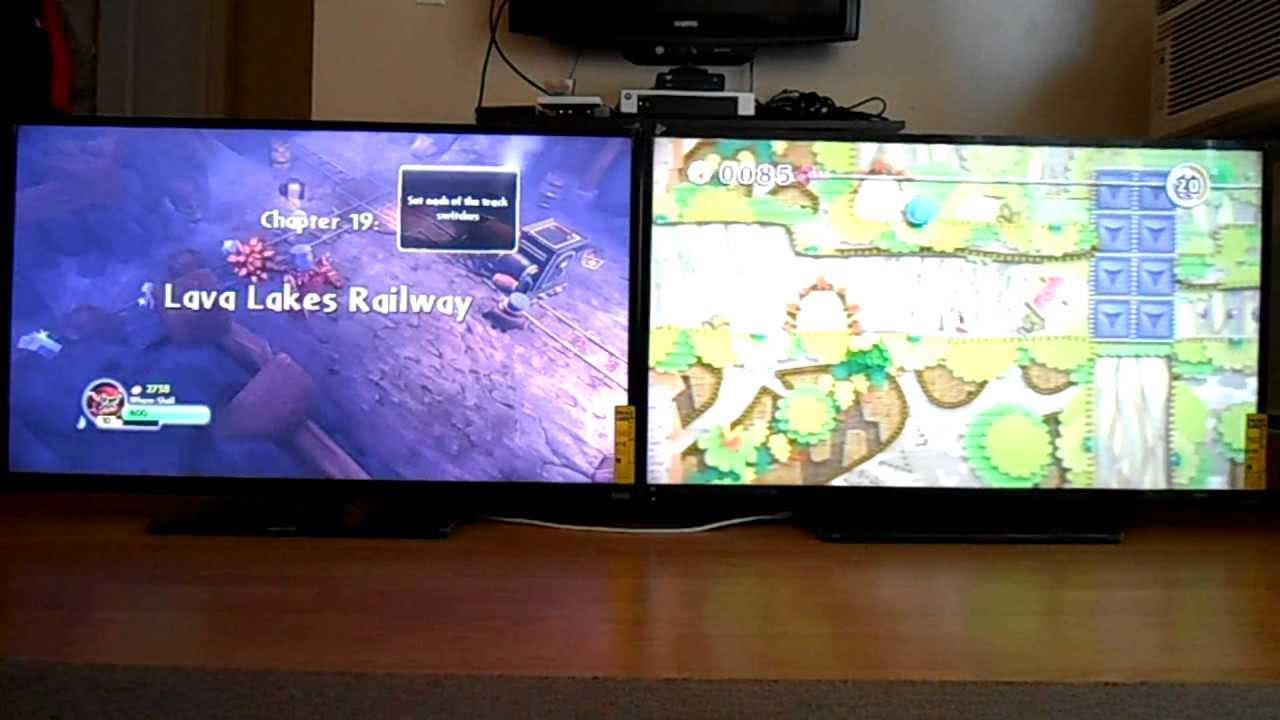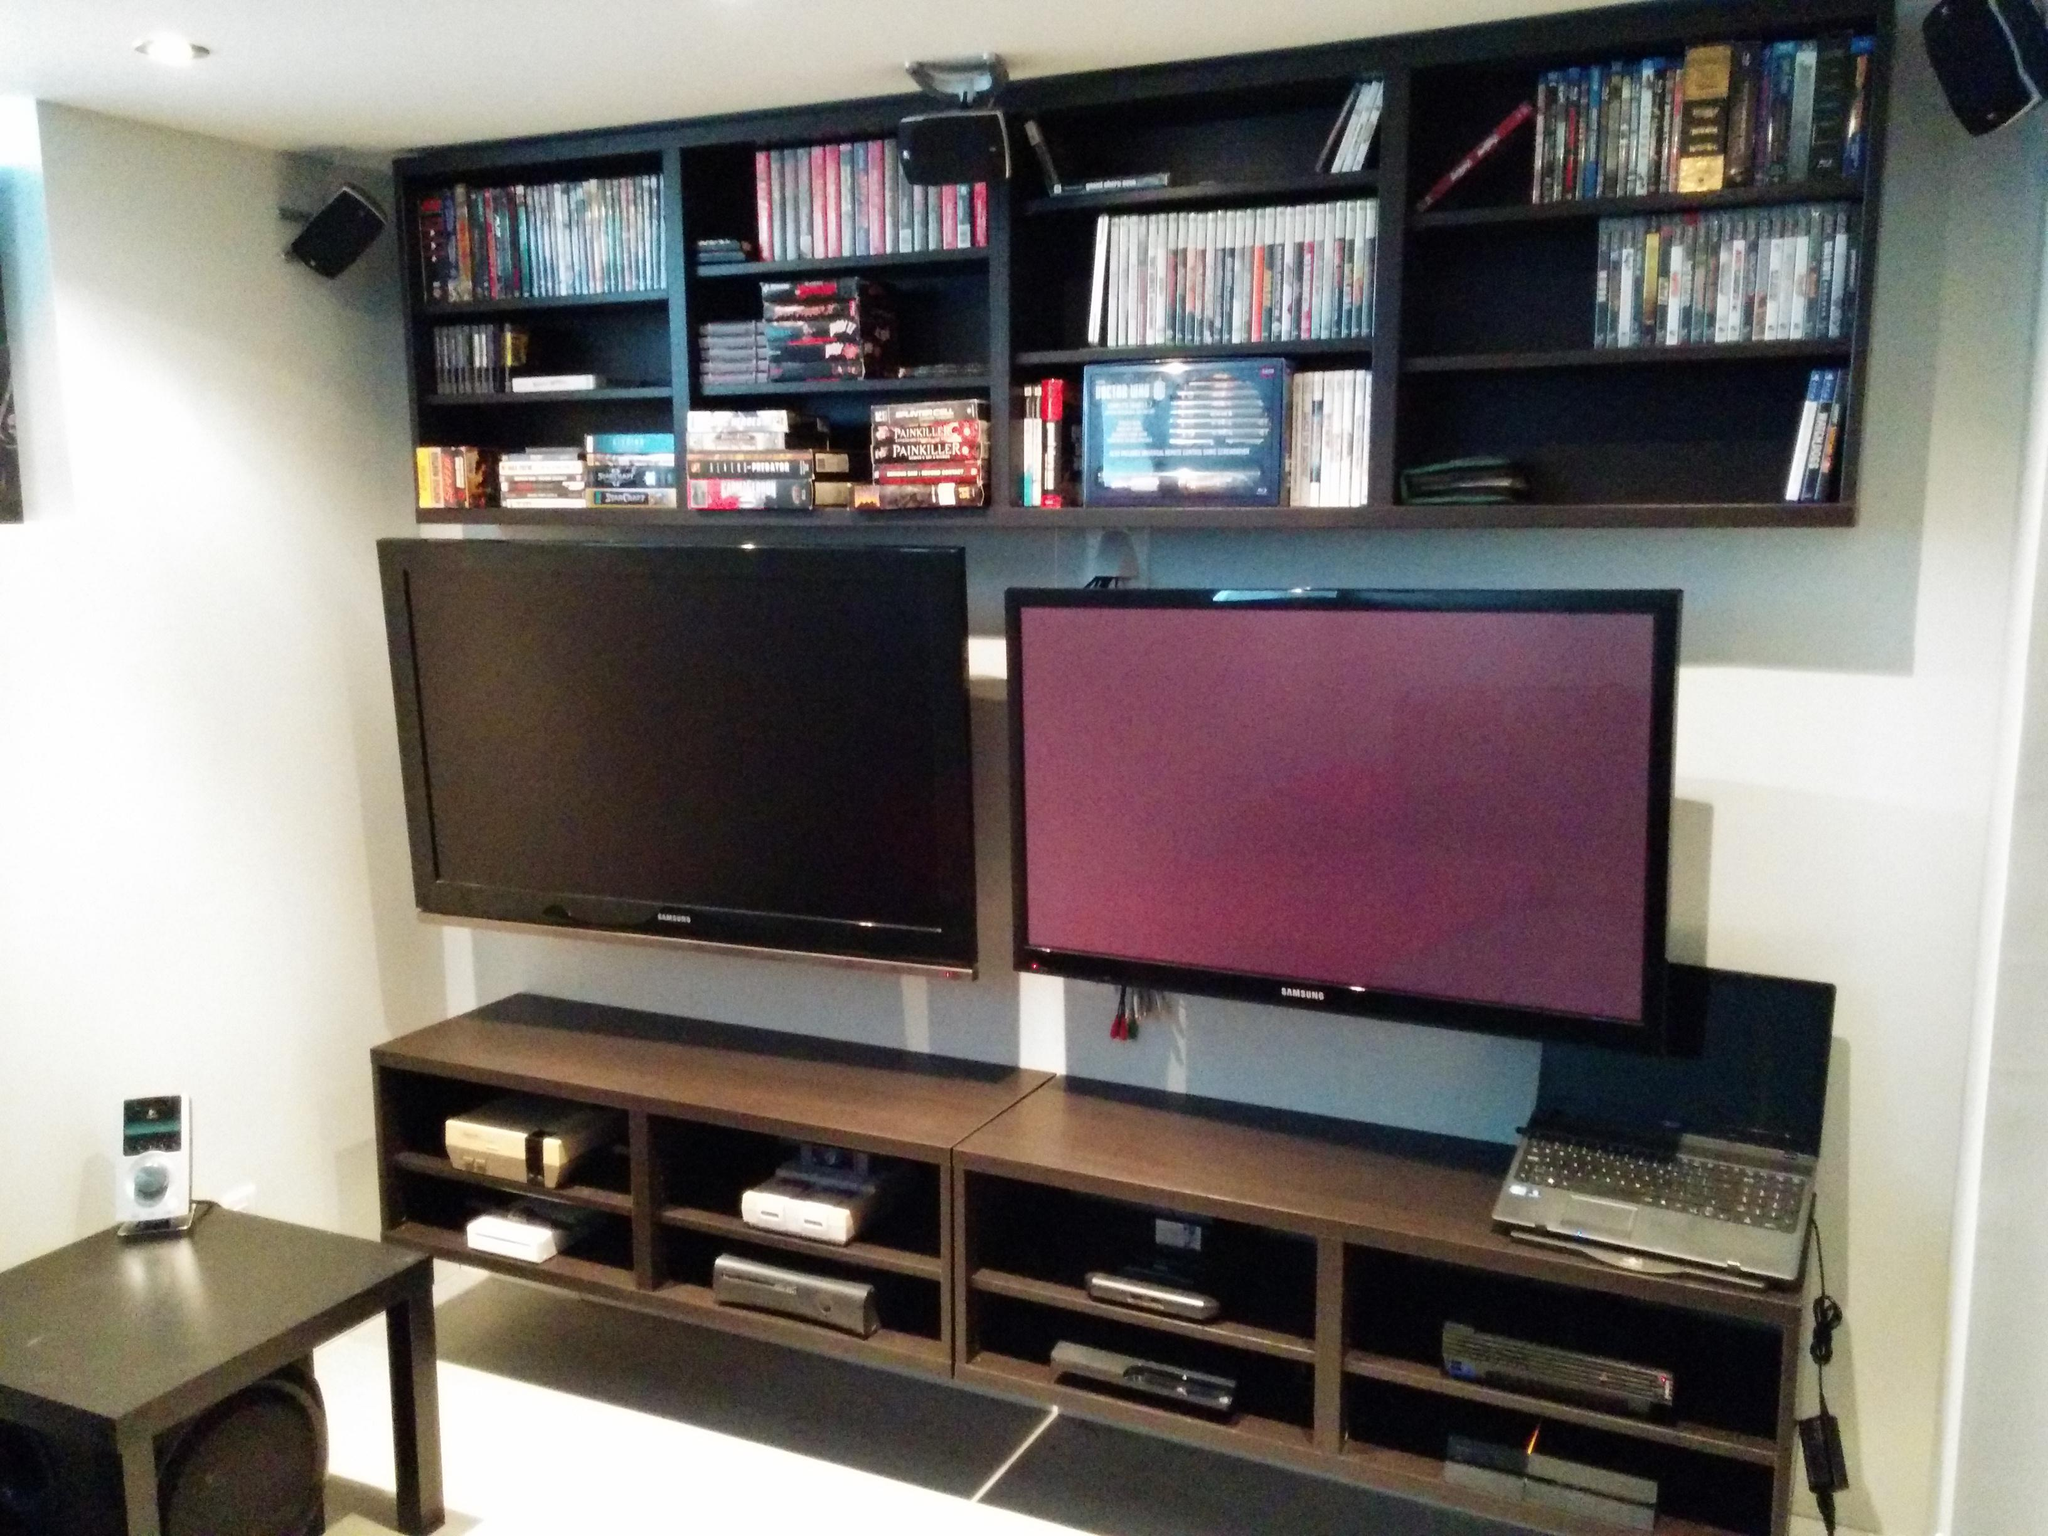The first image is the image on the left, the second image is the image on the right. Evaluate the accuracy of this statement regarding the images: "Two screens sit side by side in the image on the left.". Is it true? Answer yes or no. Yes. The first image is the image on the left, the second image is the image on the right. For the images displayed, is the sentence "An image shows multiple TV screens arranged one atop the other, and includes at least one non-standing person in front of a screen." factually correct? Answer yes or no. No. 